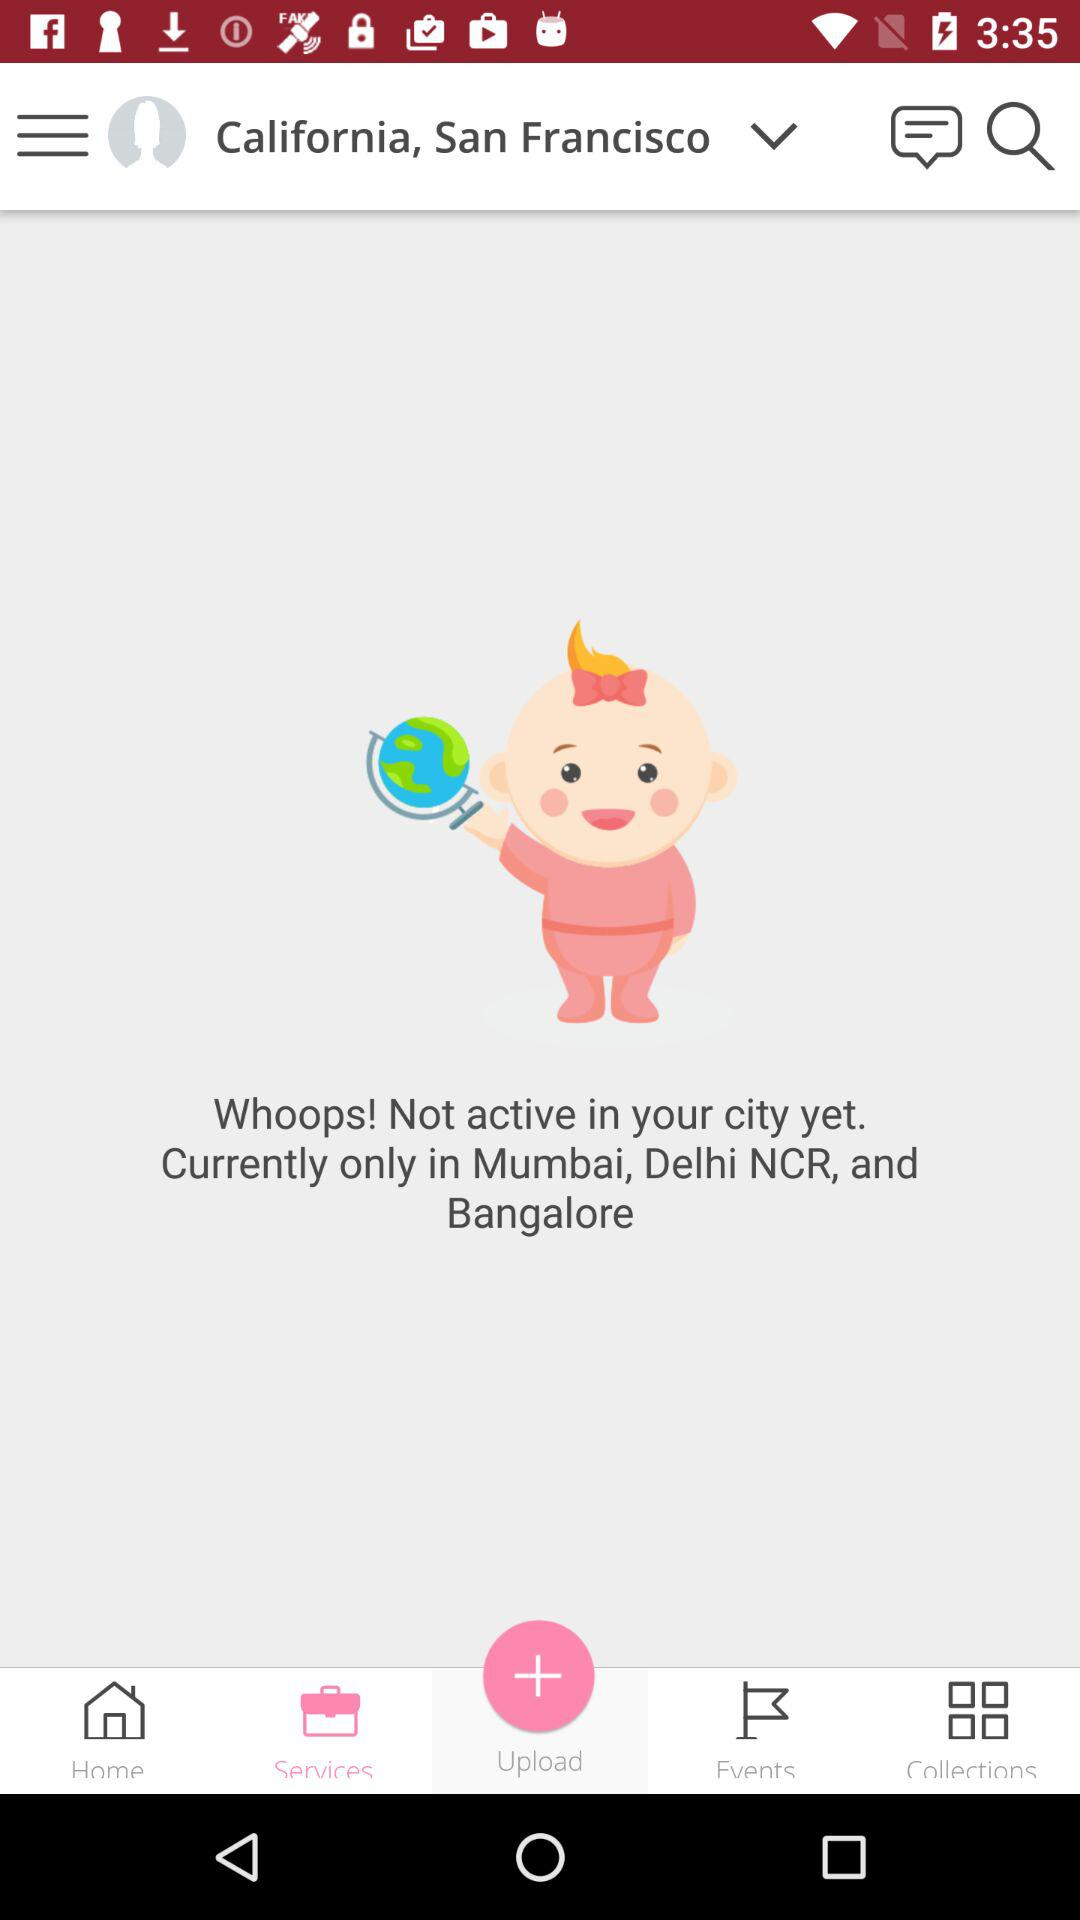Which city is selected? The selected city is San Francisco. 